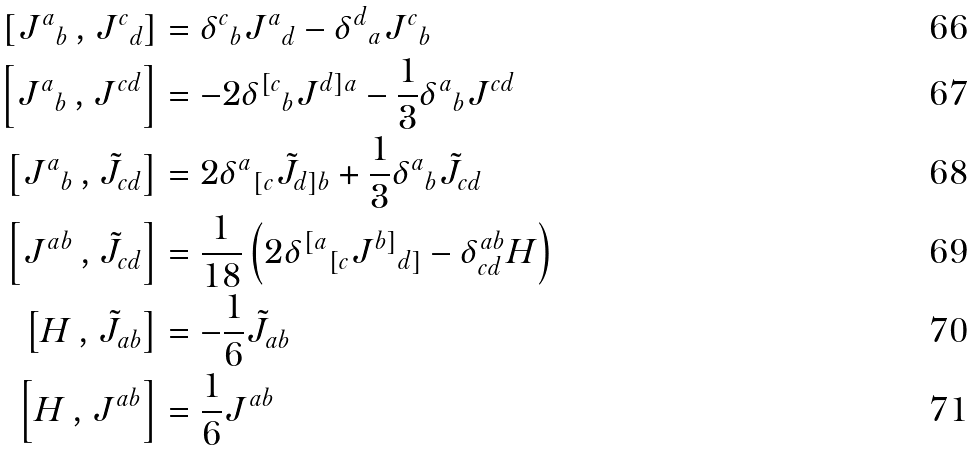<formula> <loc_0><loc_0><loc_500><loc_500>\left [ { J ^ { a } } _ { b } \, , { J ^ { c } } _ { d } \right ] & = { \delta ^ { c } } _ { b } { J ^ { a } } _ { d } - { \delta ^ { d } } _ { a } { J ^ { c } } _ { b } \\ \left [ { J ^ { a } } _ { b } \, , J ^ { c d } \right ] & = - 2 { \delta ^ { [ c } } _ { b } J ^ { d ] a } - \frac { 1 } { 3 } { \delta ^ { a } } _ { b } J ^ { c d } \\ \left [ { J ^ { a } } _ { b } \, , \tilde { J } _ { c d } \right ] & = 2 { \delta ^ { a } } _ { [ c } \tilde { J } _ { d ] b } + \frac { 1 } { 3 } { \delta ^ { a } } _ { b } \tilde { J } _ { c d } \\ \left [ J ^ { a b } \, , \tilde { J } _ { c d } \right ] & = \frac { 1 } { 1 8 } \left ( 2 { \delta ^ { [ a } } _ { [ c } { J ^ { b ] } } _ { d ] } - \delta ^ { a b } _ { c d } H \right ) \\ \left [ H \, , \tilde { J } _ { a b } \right ] & = - \frac { 1 } { 6 } \tilde { J } _ { a b } \\ \left [ H \, , J ^ { a b } \right ] & = \frac { 1 } { 6 } J ^ { a b }</formula> 